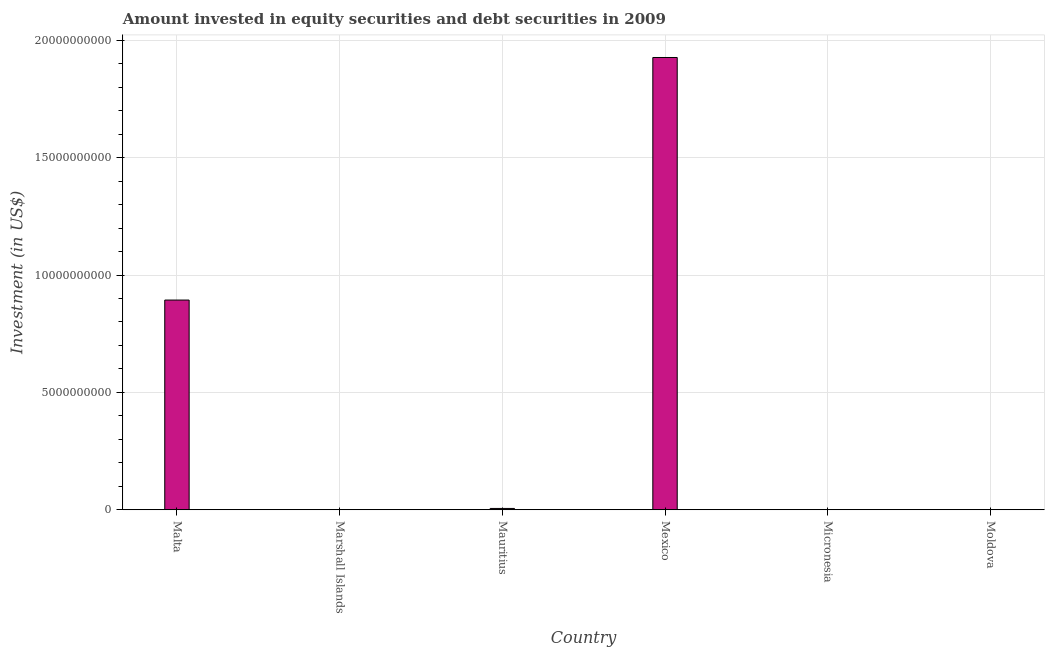Does the graph contain grids?
Your answer should be very brief. Yes. What is the title of the graph?
Offer a terse response. Amount invested in equity securities and debt securities in 2009. What is the label or title of the Y-axis?
Ensure brevity in your answer.  Investment (in US$). What is the portfolio investment in Mauritius?
Your response must be concise. 5.63e+07. Across all countries, what is the maximum portfolio investment?
Provide a succinct answer. 1.93e+1. What is the sum of the portfolio investment?
Offer a very short reply. 2.83e+1. What is the difference between the portfolio investment in Malta and Mexico?
Your answer should be compact. -1.03e+1. What is the average portfolio investment per country?
Offer a terse response. 4.71e+09. What is the median portfolio investment?
Your answer should be very brief. 3.11e+07. In how many countries, is the portfolio investment greater than 15000000000 US$?
Offer a terse response. 1. What is the ratio of the portfolio investment in Malta to that in Moldova?
Offer a very short reply. 1521.81. Is the difference between the portfolio investment in Mauritius and Moldova greater than the difference between any two countries?
Offer a very short reply. No. What is the difference between the highest and the second highest portfolio investment?
Provide a succinct answer. 1.03e+1. What is the difference between the highest and the lowest portfolio investment?
Offer a very short reply. 1.93e+1. How many bars are there?
Offer a very short reply. 4. What is the difference between two consecutive major ticks on the Y-axis?
Your response must be concise. 5.00e+09. Are the values on the major ticks of Y-axis written in scientific E-notation?
Ensure brevity in your answer.  No. What is the Investment (in US$) of Malta?
Ensure brevity in your answer.  8.93e+09. What is the Investment (in US$) in Mauritius?
Make the answer very short. 5.63e+07. What is the Investment (in US$) in Mexico?
Make the answer very short. 1.93e+1. What is the Investment (in US$) in Micronesia?
Offer a terse response. 0. What is the Investment (in US$) in Moldova?
Provide a succinct answer. 5.87e+06. What is the difference between the Investment (in US$) in Malta and Mauritius?
Ensure brevity in your answer.  8.88e+09. What is the difference between the Investment (in US$) in Malta and Mexico?
Provide a short and direct response. -1.03e+1. What is the difference between the Investment (in US$) in Malta and Moldova?
Ensure brevity in your answer.  8.93e+09. What is the difference between the Investment (in US$) in Mauritius and Mexico?
Your answer should be very brief. -1.92e+1. What is the difference between the Investment (in US$) in Mauritius and Moldova?
Ensure brevity in your answer.  5.05e+07. What is the difference between the Investment (in US$) in Mexico and Moldova?
Your answer should be compact. 1.93e+1. What is the ratio of the Investment (in US$) in Malta to that in Mauritius?
Give a very brief answer. 158.59. What is the ratio of the Investment (in US$) in Malta to that in Mexico?
Your response must be concise. 0.46. What is the ratio of the Investment (in US$) in Malta to that in Moldova?
Keep it short and to the point. 1521.81. What is the ratio of the Investment (in US$) in Mauritius to that in Mexico?
Offer a very short reply. 0. What is the ratio of the Investment (in US$) in Mauritius to that in Moldova?
Offer a very short reply. 9.6. What is the ratio of the Investment (in US$) in Mexico to that in Moldova?
Your answer should be very brief. 3282.06. 